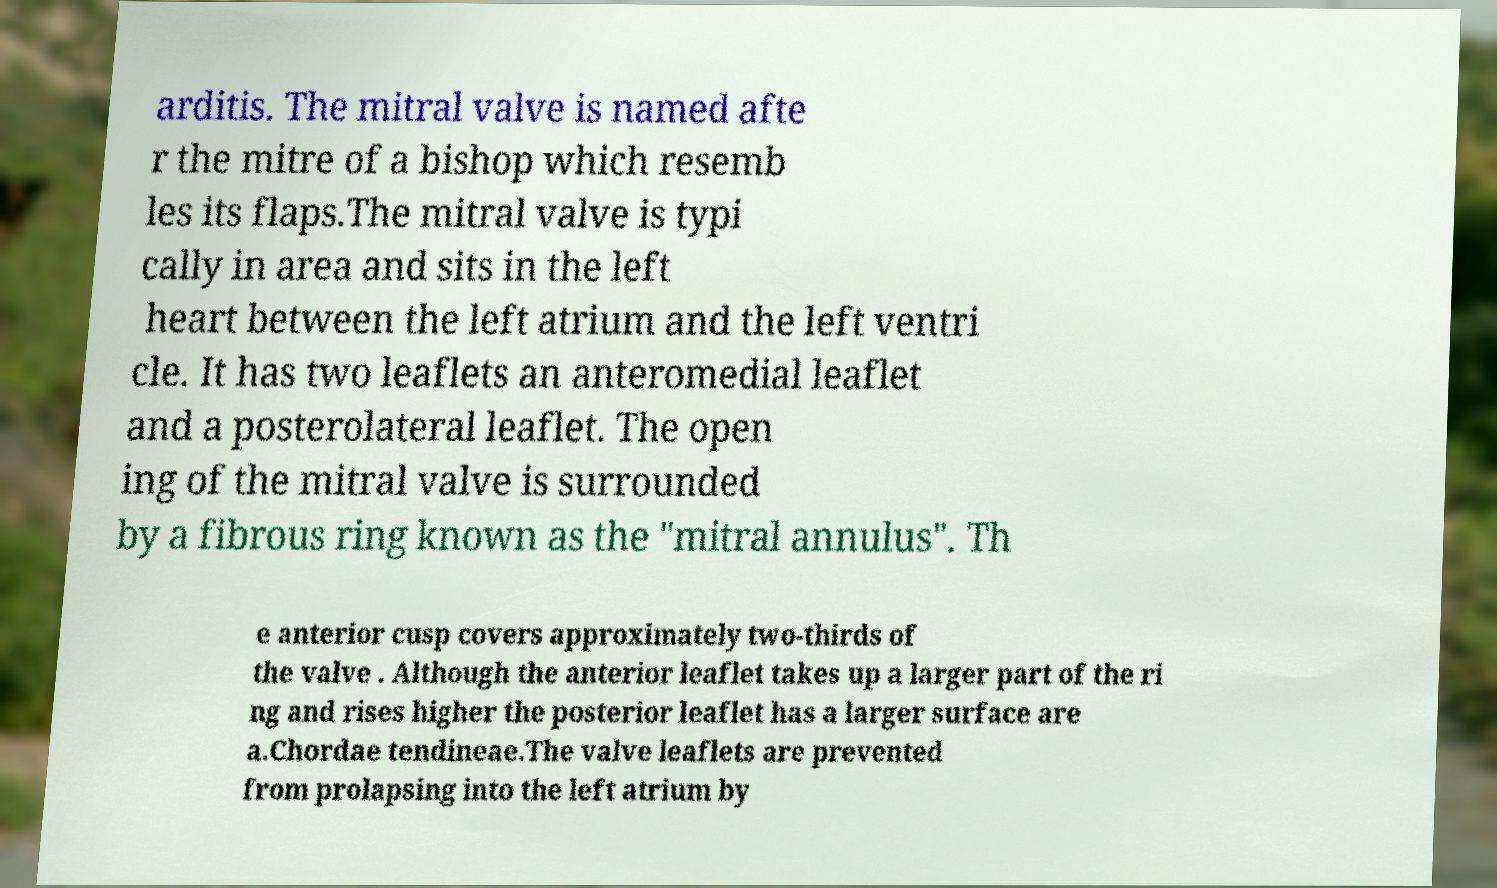What messages or text are displayed in this image? I need them in a readable, typed format. arditis. The mitral valve is named afte r the mitre of a bishop which resemb les its flaps.The mitral valve is typi cally in area and sits in the left heart between the left atrium and the left ventri cle. It has two leaflets an anteromedial leaflet and a posterolateral leaflet. The open ing of the mitral valve is surrounded by a fibrous ring known as the "mitral annulus". Th e anterior cusp covers approximately two-thirds of the valve . Although the anterior leaflet takes up a larger part of the ri ng and rises higher the posterior leaflet has a larger surface are a.Chordae tendineae.The valve leaflets are prevented from prolapsing into the left atrium by 